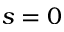Convert formula to latex. <formula><loc_0><loc_0><loc_500><loc_500>s = 0</formula> 